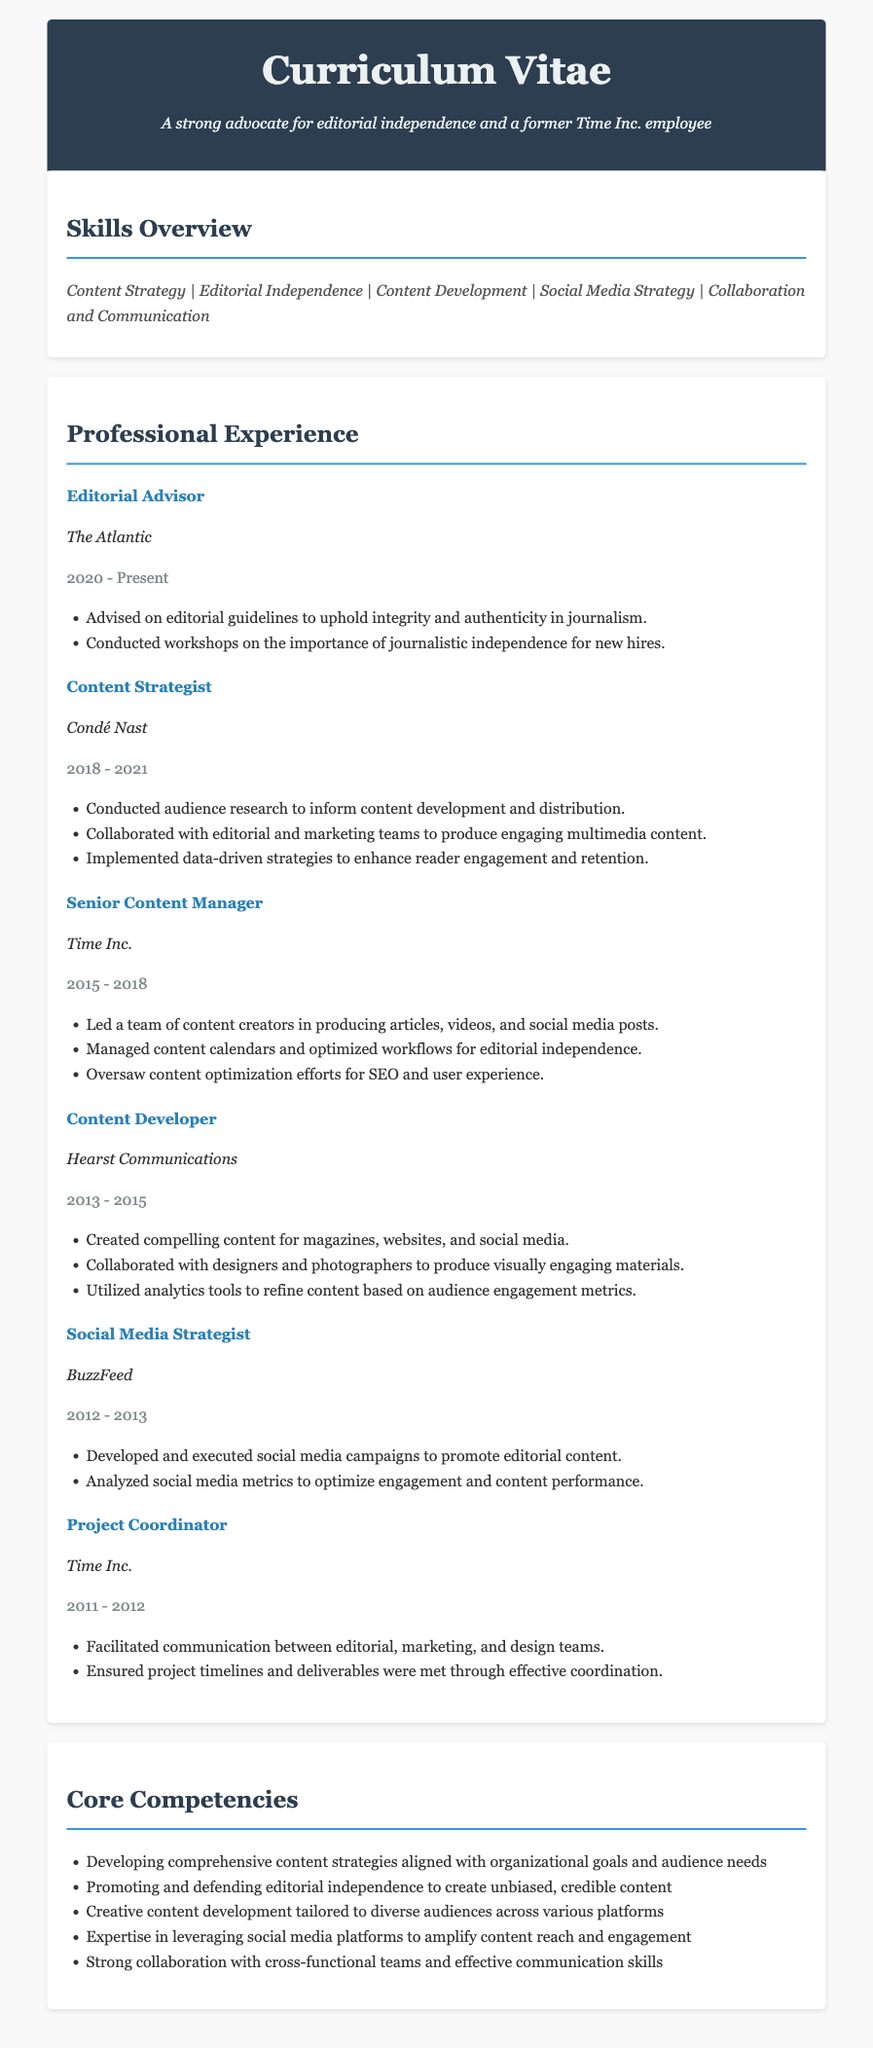what is the current position held? The document indicates the current position as Editorial Advisor at The Atlantic from 2020 to Present.
Answer: Editorial Advisor which company did the individual work for last before The Atlantic? In the document, the last position before The Atlantic was held at Condé Nast as a Content Strategist.
Answer: Condé Nast how many years of experience does the individual have at Time Inc.? The document lists two positions at Time Inc., totaling from 2011 to 2018, which is 7 years.
Answer: 7 years what role involved social media campaigns? The document specifies the role of Social Media Strategist at BuzzFeed involved social media campaigns.
Answer: Social Media Strategist what is one of the core competencies highlighted in the document? The document lists multiple core competencies, such as developing comprehensive content strategies aligned with organizational goals and audience needs.
Answer: Comprehensive content strategies who is responsible for advising on editorial guidelines? The document indicates that the Editorial Advisor role involves advising on editorial guidelines.
Answer: Editorial Advisor during which years did the individual work as a Content Developer? The Content Developer role at Hearst Communications is listed as being from 2013 to 2015.
Answer: 2013 - 2015 what was a key responsibility of the Senior Content Manager? The document asserts that a key responsibility of the Senior Content Manager was leading a team of content creators.
Answer: Leading a team of content creators which skill emphasizes collaboration and communication? In the Skills Overview section, collaboration and communication appears as a key skill area.
Answer: Collaboration and Communication 